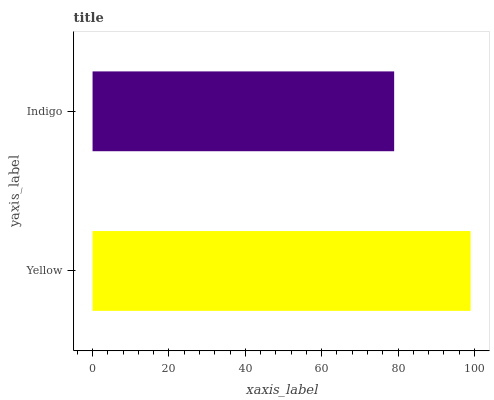Is Indigo the minimum?
Answer yes or no. Yes. Is Yellow the maximum?
Answer yes or no. Yes. Is Indigo the maximum?
Answer yes or no. No. Is Yellow greater than Indigo?
Answer yes or no. Yes. Is Indigo less than Yellow?
Answer yes or no. Yes. Is Indigo greater than Yellow?
Answer yes or no. No. Is Yellow less than Indigo?
Answer yes or no. No. Is Yellow the high median?
Answer yes or no. Yes. Is Indigo the low median?
Answer yes or no. Yes. Is Indigo the high median?
Answer yes or no. No. Is Yellow the low median?
Answer yes or no. No. 